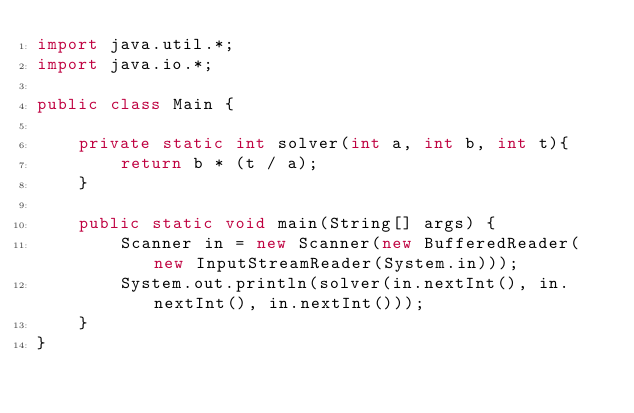<code> <loc_0><loc_0><loc_500><loc_500><_Java_>import java.util.*;
import java.io.*;

public class Main {

    private static int solver(int a, int b, int t){
        return b * (t / a);
    }

    public static void main(String[] args) {
        Scanner in = new Scanner(new BufferedReader(new InputStreamReader(System.in)));
        System.out.println(solver(in.nextInt(), in.nextInt(), in.nextInt()));
    }
}
</code> 